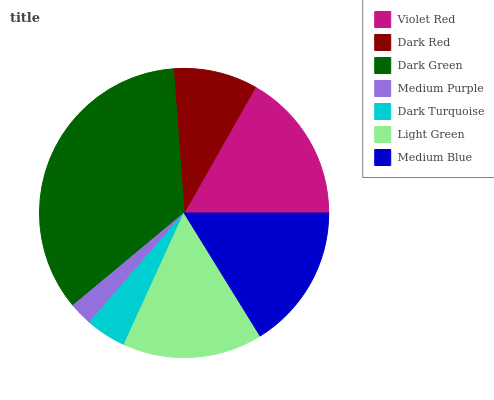Is Medium Purple the minimum?
Answer yes or no. Yes. Is Dark Green the maximum?
Answer yes or no. Yes. Is Dark Red the minimum?
Answer yes or no. No. Is Dark Red the maximum?
Answer yes or no. No. Is Violet Red greater than Dark Red?
Answer yes or no. Yes. Is Dark Red less than Violet Red?
Answer yes or no. Yes. Is Dark Red greater than Violet Red?
Answer yes or no. No. Is Violet Red less than Dark Red?
Answer yes or no. No. Is Light Green the high median?
Answer yes or no. Yes. Is Light Green the low median?
Answer yes or no. Yes. Is Dark Red the high median?
Answer yes or no. No. Is Dark Red the low median?
Answer yes or no. No. 